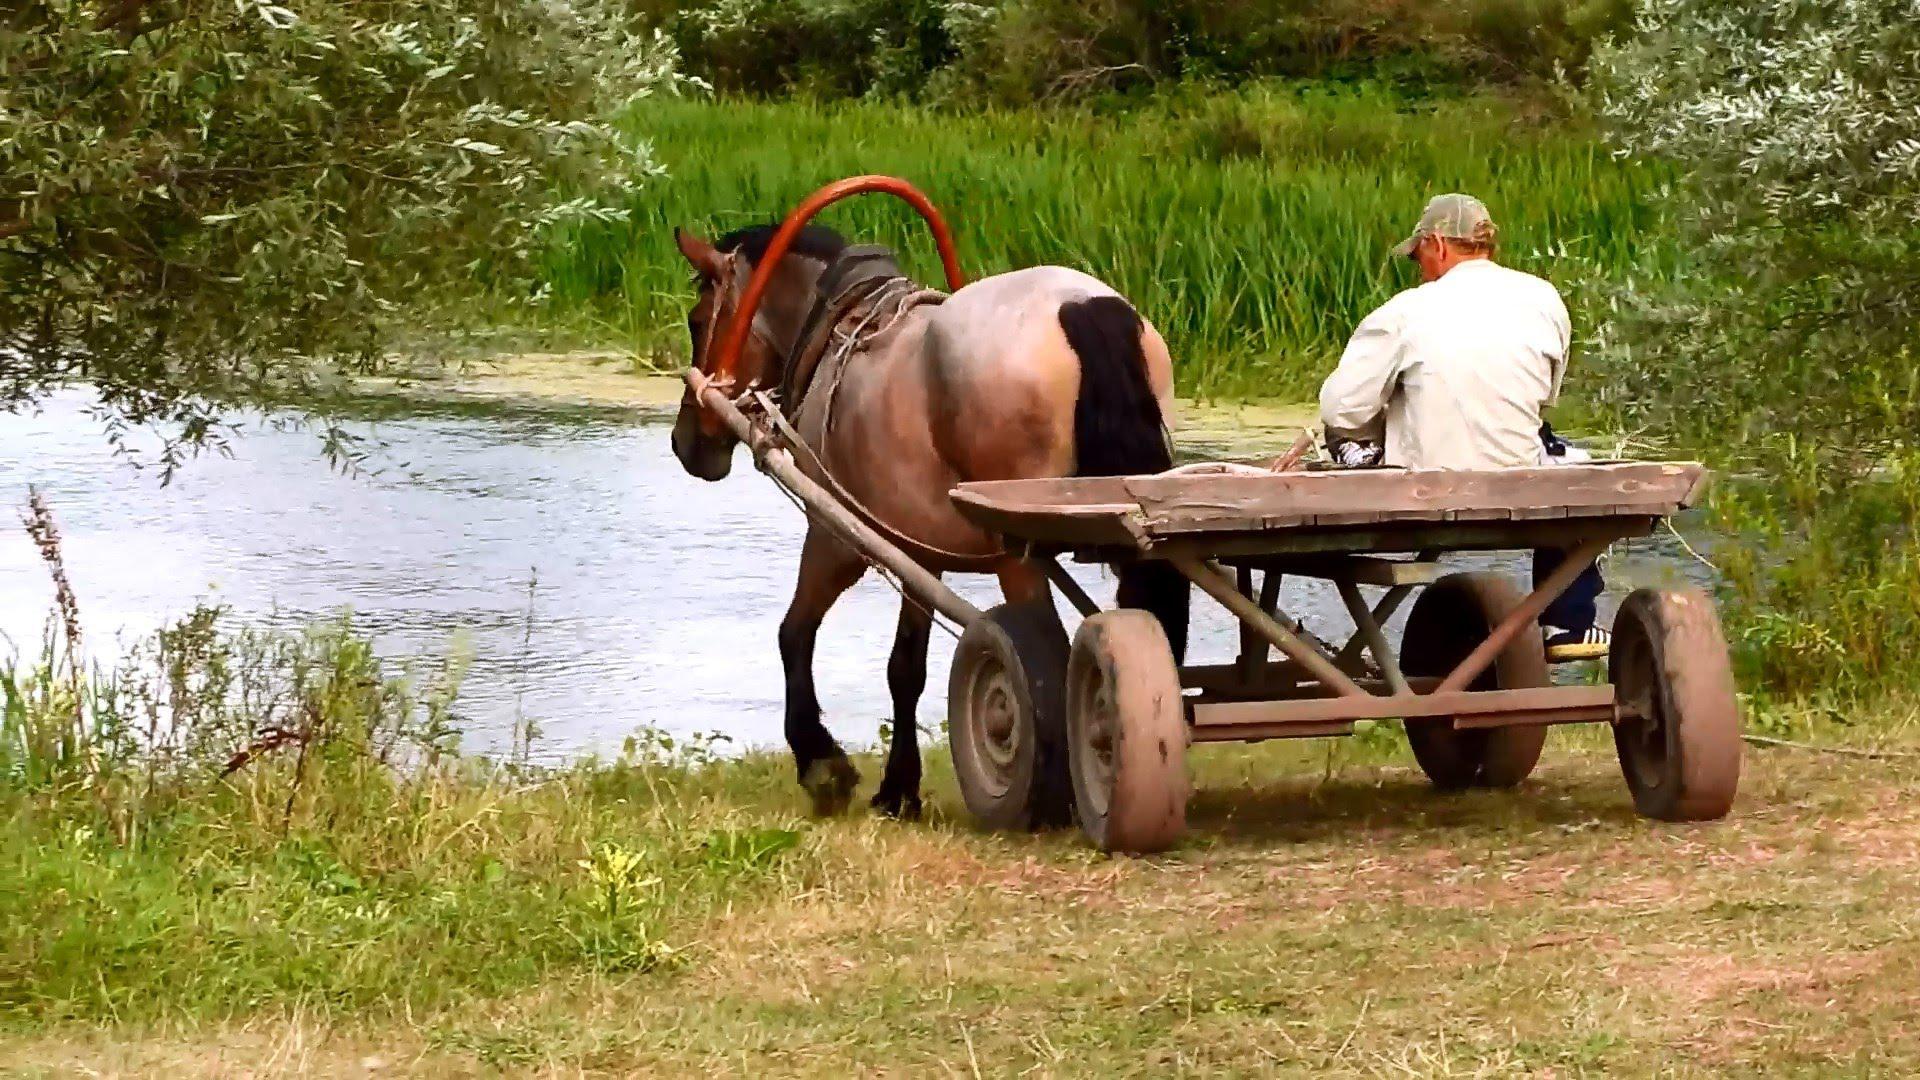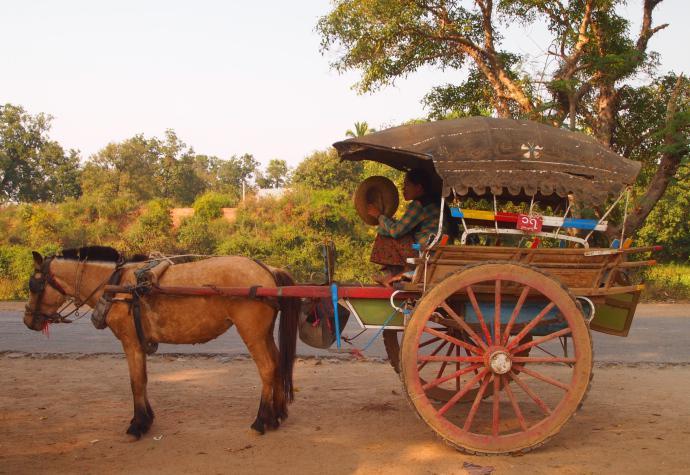The first image is the image on the left, the second image is the image on the right. Given the left and right images, does the statement "All the carriages are facing left." hold true? Answer yes or no. Yes. 